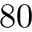Convert formula to latex. <formula><loc_0><loc_0><loc_500><loc_500>8 0</formula> 